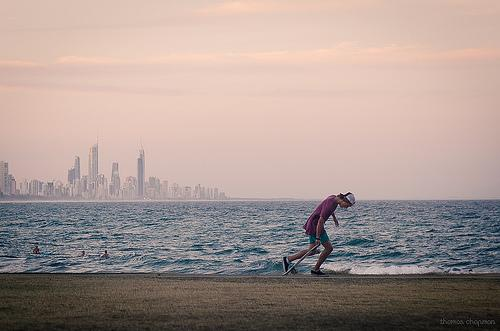Craft a short tale describing the boy with the skateboard and his surroundings. On a sunny day by the beach, a boy in a hat and purple shirt adventures on his skateboard, passing the lively ocean where fellow beach-goers swim and a person walks in the water, all under the watchful eye of the sprawling city skyline. Describe the setting of this image. The image is set on a beach with a sidewalk, ocean waves, sand, and a city skyline in the background as people engage in various activities. Describe the various elements in the image, focusing on the boy, the beach, and the city skyline. The image shows a boy skateboarding near the beach, wearing a hat and casual clothes, with people swimming in the ocean, waves crashing, sand and grass nearby, and a city skyline in the background. Explain what the person walking along the beach is experiencing. The person walking along the beach is enjoying the ocean, getting their feet wet, wearing a hat, and taking in the picturesque city view. Mention the notable features of the image's background. In the background, there is a city skyline with large buildings, grass growing on the ground, and clouds in the sky. What is the most prominent action taking place on the beach in this image? A boy is skateboarding on the sidewalk near the beach, with the ocean and city skyline as his backdrop. Provide an account of the people's activities taking place in the ocean. In the ocean, people are swimming, enjoying the water, and experiencing the crashing waves on the shore. Narrate what the boy on the skateboard is doing and what he is wearing. The boy on the skateboard is riding on the sidewalk near the beach, wearing a purple shirt, shorts, shoes, and a white cap. Provide a brief summary of what is happening in the image. A boy is skateboarding near the beach with a view of the city skyline, while people enjoy swimming in the ocean and a person with a hat walks along the shore. Enumerate the clothing items and accessories visible on the skateboarder. The skateboarder is wearing a purple shirt, shorts, shoes, and a white cap, while holding a wooden skateboard in his hand. 